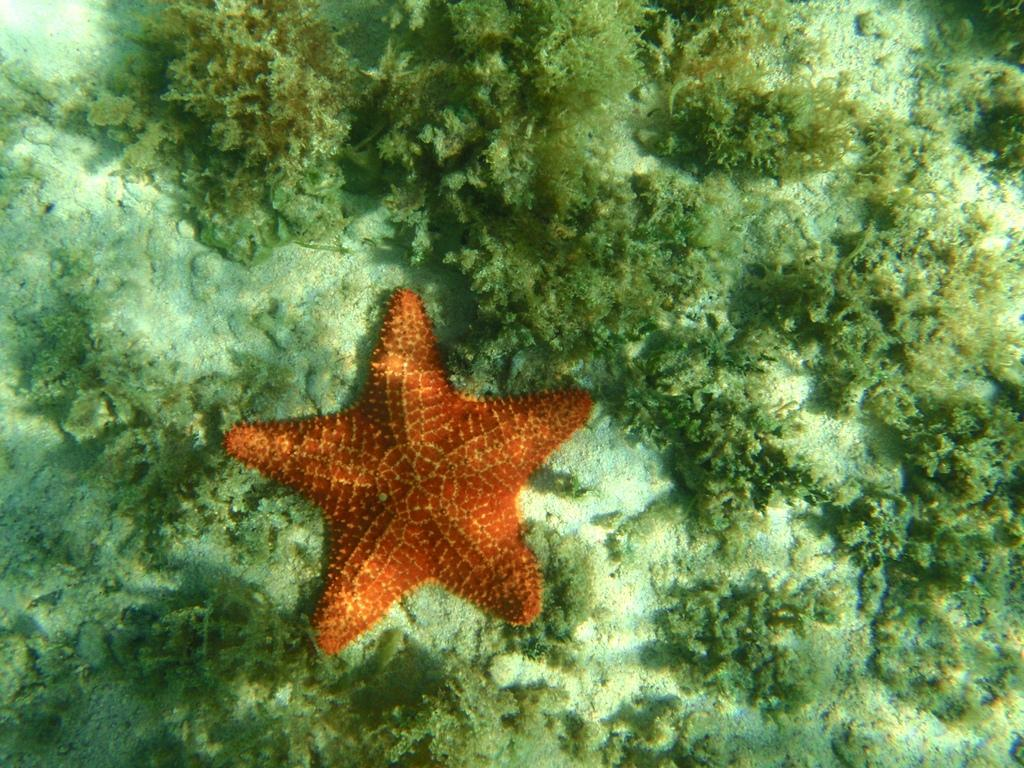What is the setting of the image? The image is taken underwater. What can be seen in the center of the image? There is a starfish in the center of the image. What type of vegetation is visible in the image? There are water plants visible in the image. What type of terrain is present in the image? Sand is present in the image. What historical event is being commemorated by the alarm in the image? There is no alarm present in the image, and therefore no historical event can be associated with it. 